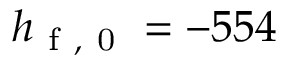<formula> <loc_0><loc_0><loc_500><loc_500>h _ { f , 0 } = - 5 5 4</formula> 